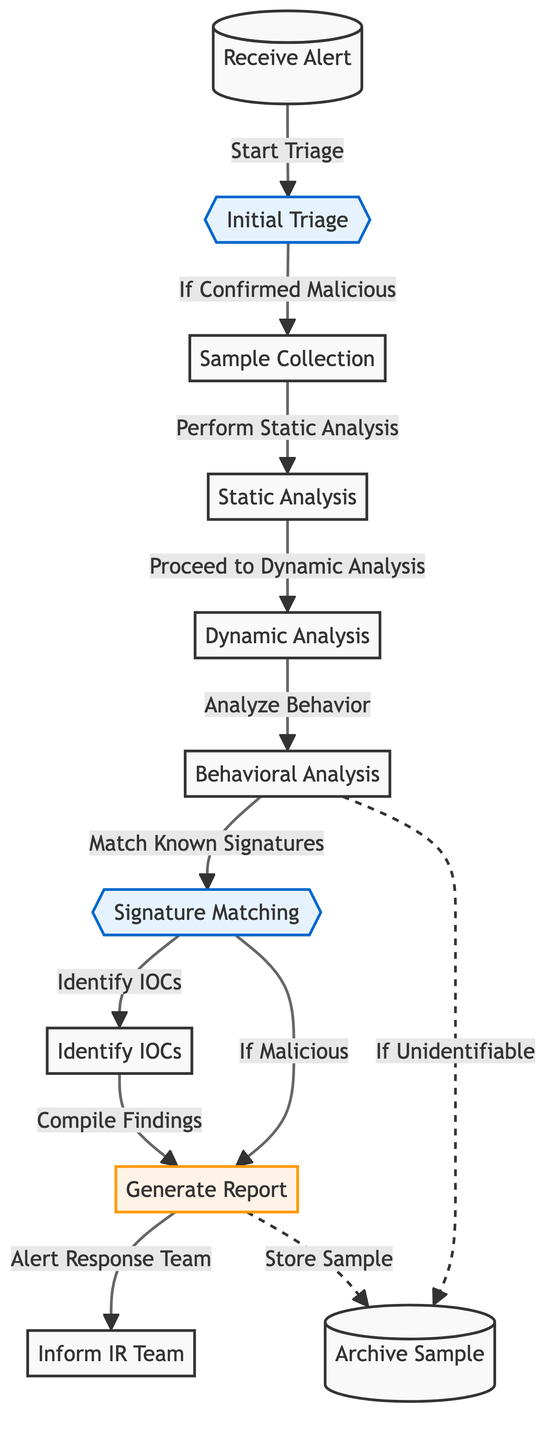What is the first step in the daily workflow of malware analysis? The first step is indicated by the starting point of the diagram, which is "Receive Alert" before proceeding to "Initial Triage".
Answer: Receive Alert How many decision points are in the diagram? The decision points are marked with double curly braces. There are two decision points: "Initial Triage" and "Signature Matching".
Answer: 2 What is the purpose of the node labeled "Identify IOCs"? "Identify IOCs" is a key step after "Signature Matching," indicating it is about identifying Indicators of Compromise during the analysis process.
Answer: Identify Indicators of Compromise What happens if the sample is confirmed malicious at "Initial Triage"? If confirmed malicious, the workflow proceeds to "Sample Collection" as indicated by the directed flow from "Initial Triage".
Answer: Sample Collection What are the last two steps after generating the report? After generating the report, the workflow outlines alerting the Response Team and optionally storing the sample, as represented by the connection from "Generate Report" to "Inform IR Team" and to "Archive Sample".
Answer: Inform IR Team, Archive Sample If dynamic analysis results in unidentifiable behavior, what step does the workflow take? The diagram indicates that if the behavior is unidentifiable during the "Behavioral Analysis", it directs the workflow to "Archive Sample", demonstrating that identification has not been achieved.
Answer: Archive Sample Which process follows "Static Analysis"? After "Static Analysis," the diagram shows the workflow moves to "Dynamic Analysis", demonstrating the logical sequence of analysis steps.
Answer: Dynamic Analysis What indicates a successful identification at "Signature Matching"? The workflow shows that successful identification at this decision point leads to "Generate Report", indicating that the malware behavior matches known signatures.
Answer: Generate Report 